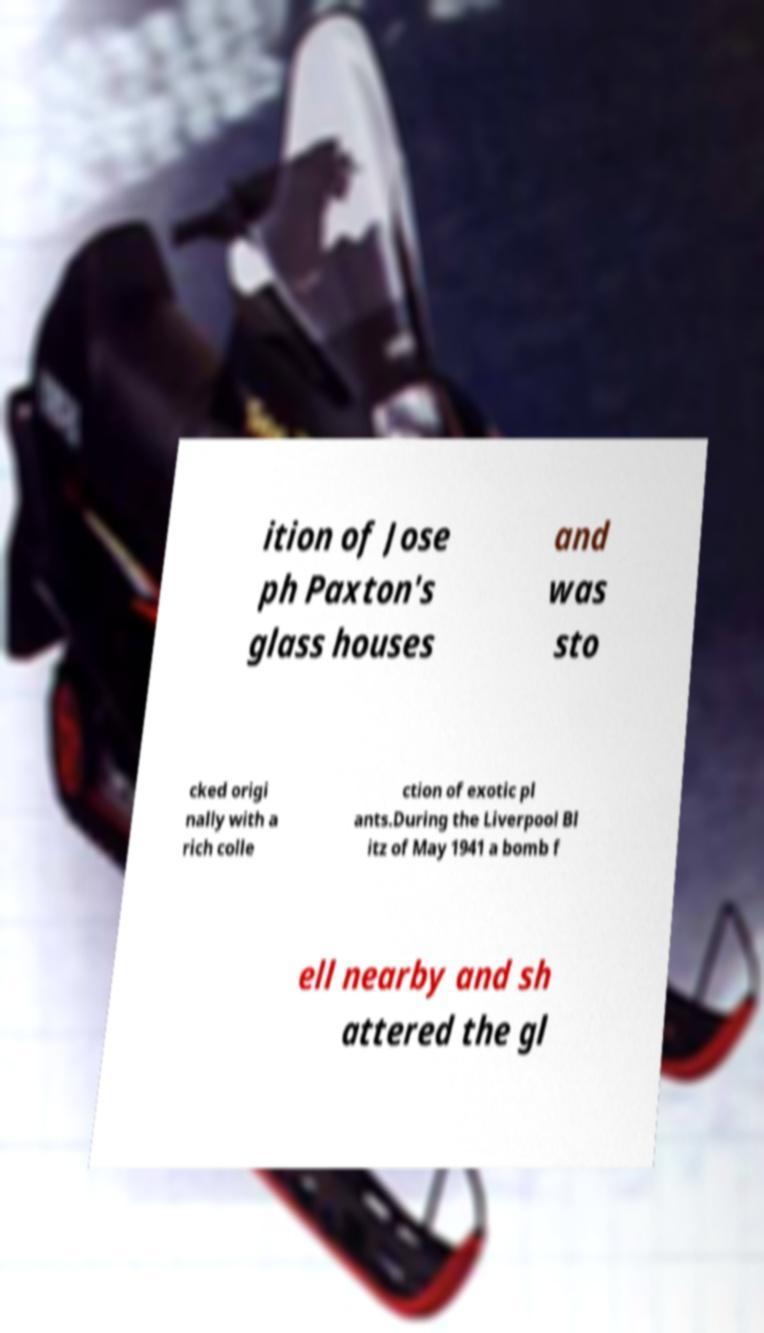Could you extract and type out the text from this image? ition of Jose ph Paxton's glass houses and was sto cked origi nally with a rich colle ction of exotic pl ants.During the Liverpool Bl itz of May 1941 a bomb f ell nearby and sh attered the gl 